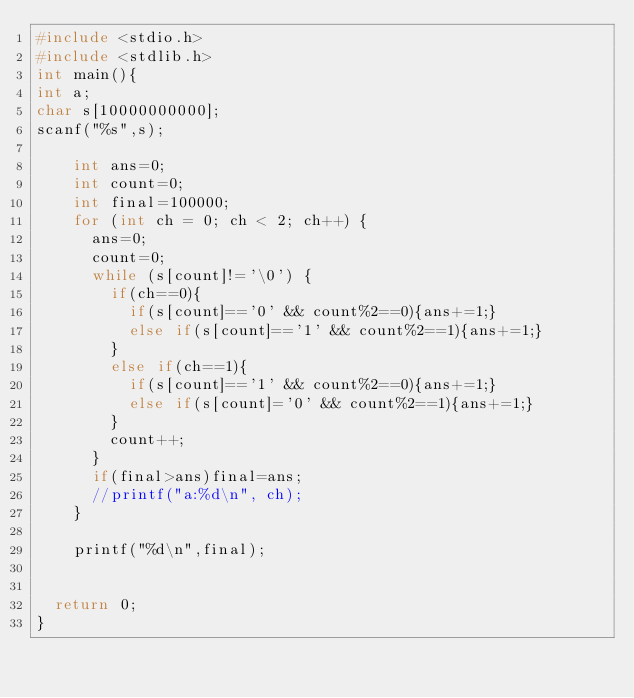<code> <loc_0><loc_0><loc_500><loc_500><_C_>#include <stdio.h>
#include <stdlib.h>
int main(){
int a;
char s[10000000000];
scanf("%s",s);

    int ans=0;
    int count=0;
    int final=100000;
    for (int ch = 0; ch < 2; ch++) {
      ans=0;
      count=0;
      while (s[count]!='\0') {
        if(ch==0){
          if(s[count]=='0' && count%2==0){ans+=1;}
          else if(s[count]=='1' && count%2==1){ans+=1;}
        }
        else if(ch==1){
          if(s[count]=='1' && count%2==0){ans+=1;}
          else if(s[count]='0' && count%2==1){ans+=1;}
        }
        count++;
      }
      if(final>ans)final=ans;
      //printf("a:%d\n", ch);
    }

    printf("%d\n",final);


  return 0;
}
</code> 